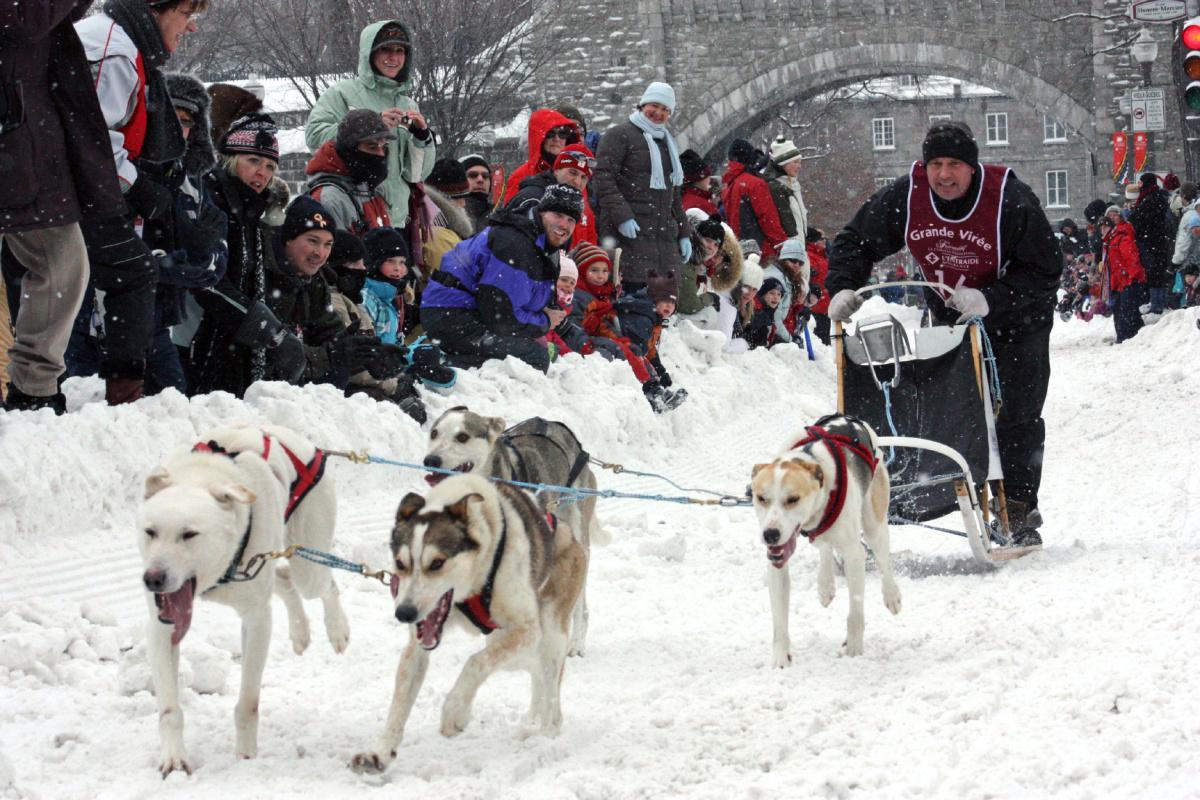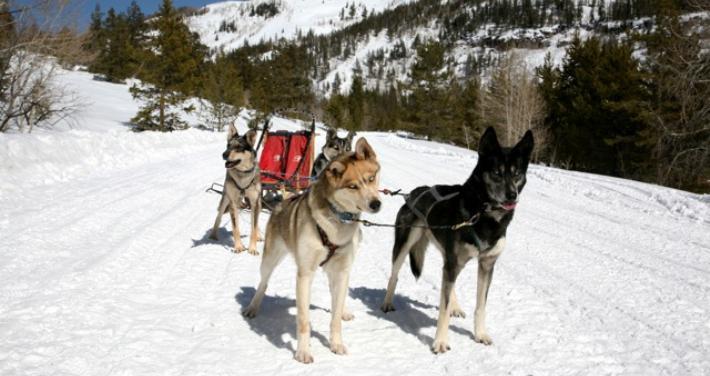The first image is the image on the left, the second image is the image on the right. Examine the images to the left and right. Is the description "At least one man is riding a sled wearing a white vest that is numbered." accurate? Answer yes or no. No. The first image is the image on the left, the second image is the image on the right. Evaluate the accuracy of this statement regarding the images: "The person driving the sled in the image on the right is wearing a white numbered vest.". Is it true? Answer yes or no. No. 